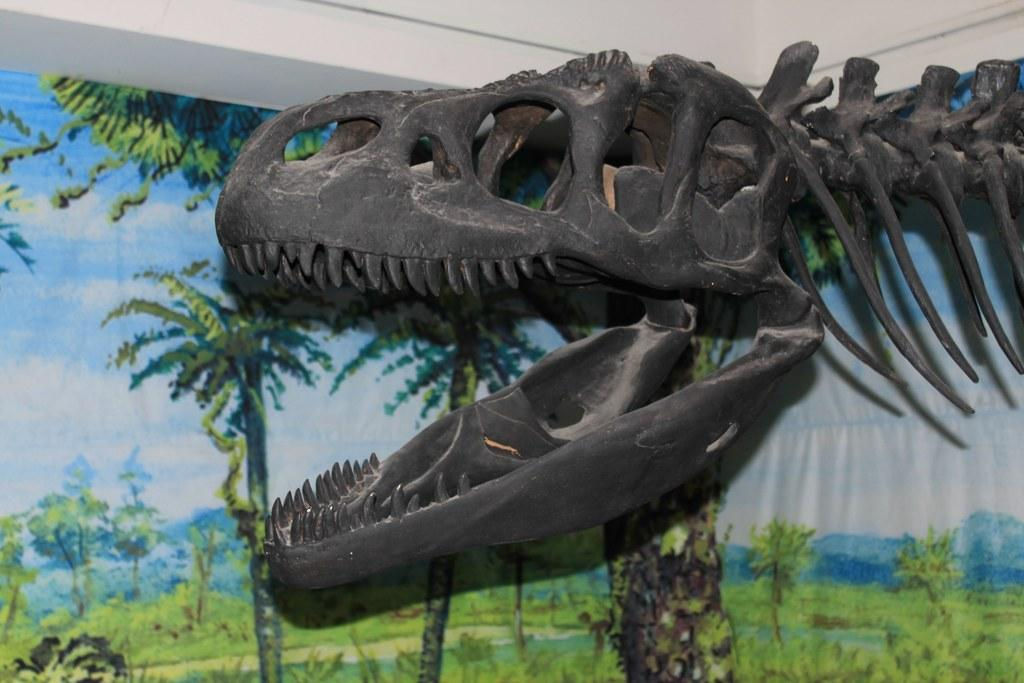What is the main subject of the picture? The main subject of the picture is a skull of an animal. What else is present in the picture besides the skull? There is a cloth with a painting and trees visible in the picture. What type of pig can be seen tied to a cord in the picture? There is no pig or cord present in the picture; it features a skull of an animal and a cloth with a painting. 